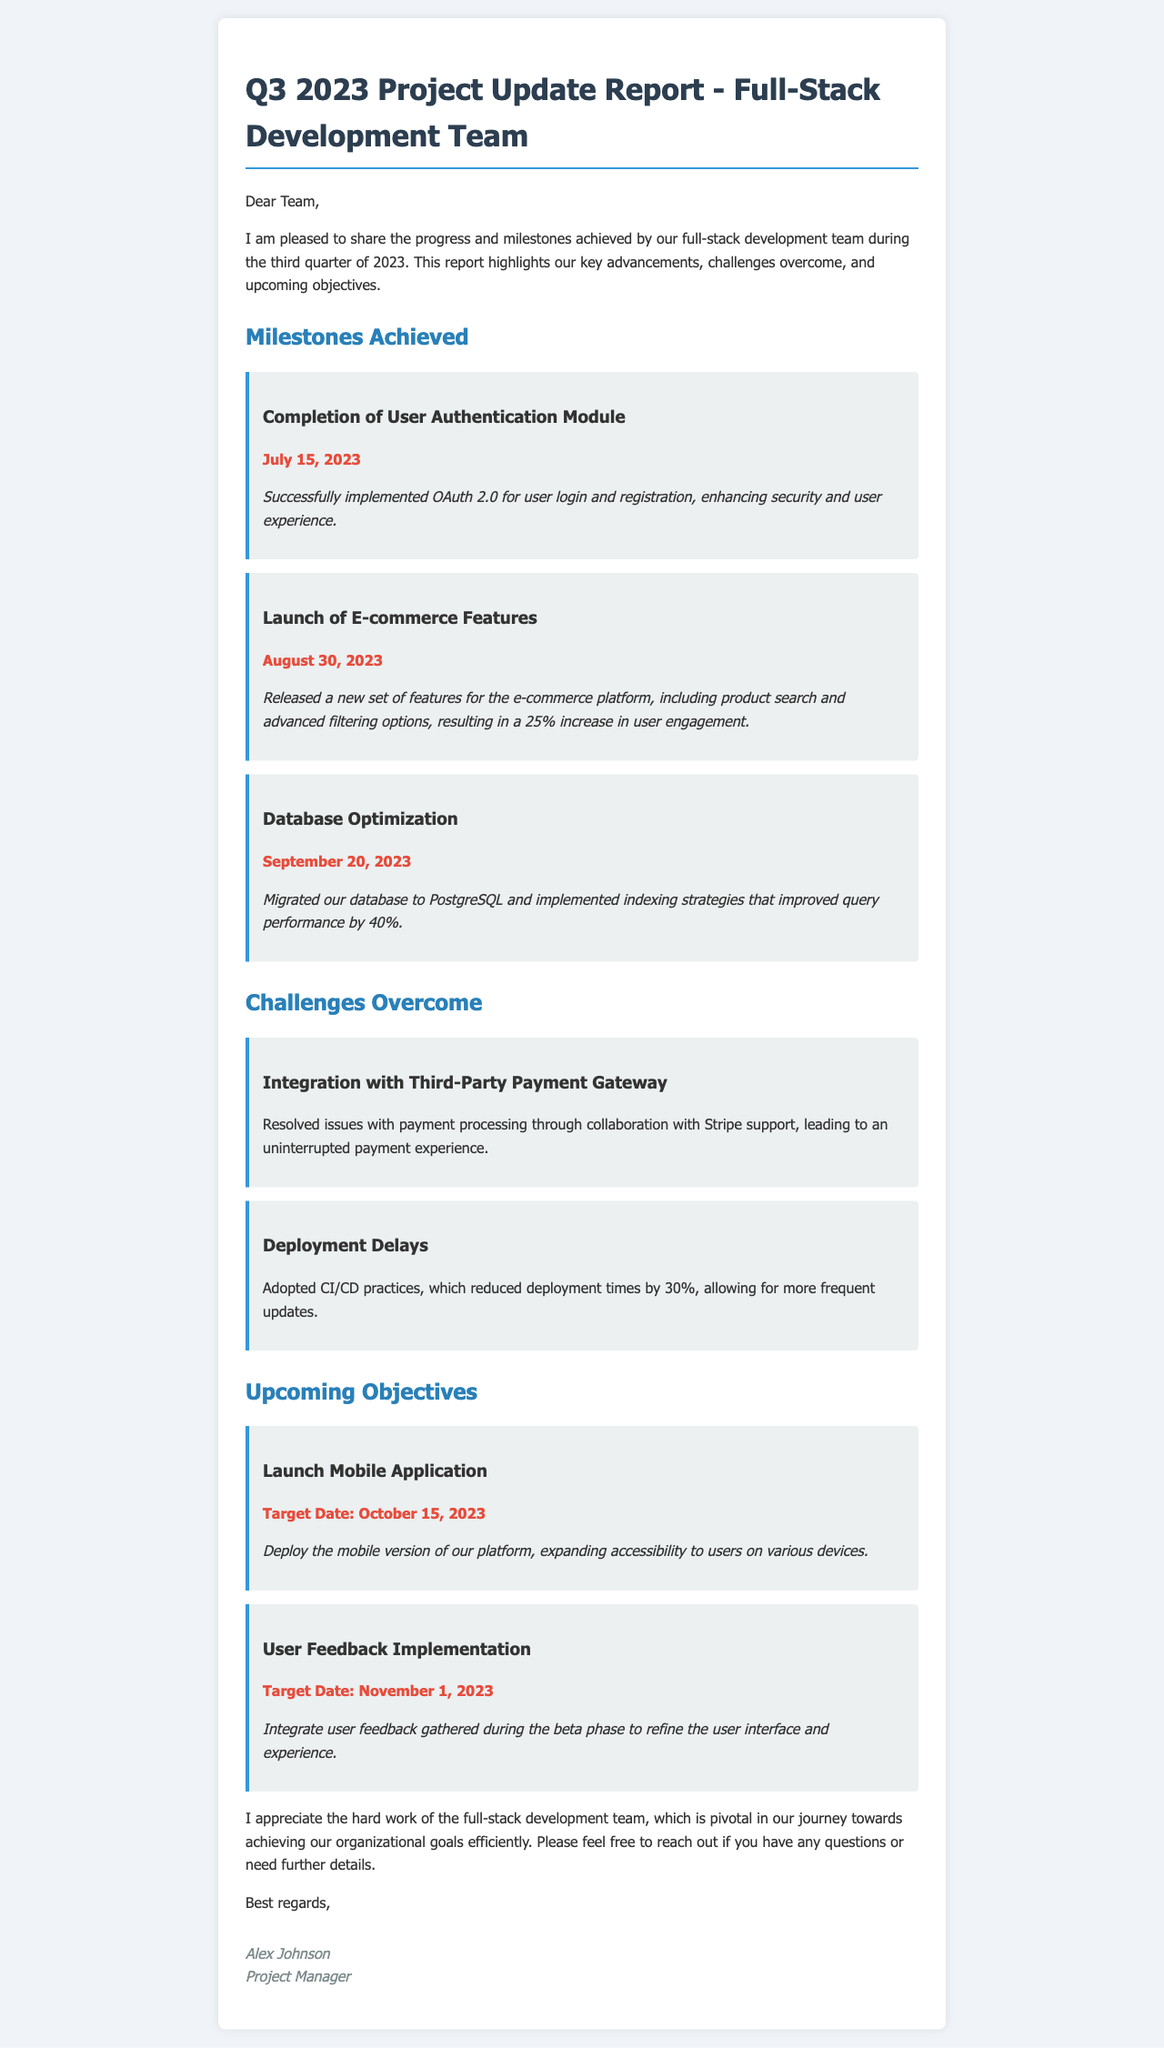What is the title of the report? The title of the report is stated at the top of the document, which is "Q3 2023 Project Update Report - Full-Stack Development Team".
Answer: Q3 2023 Project Update Report - Full-Stack Development Team When was the user authentication module completed? The completion date is explicitly mentioned in the milestones section for the user authentication module, which is July 15, 2023.
Answer: July 15, 2023 What improvement was achieved in query performance? This information is provided in the milestones section regarding database optimization, stating a 40% improvement in query performance.
Answer: 40% What feature release contributed to a 25% increase in user engagement? The document indicates that the launch of e-commerce features resulted in a 25% increase in user engagement.
Answer: E-commerce Features What method did the team adopt to reduce deployment times? The document notes the adoption of CI/CD practices to reduce deployment times, highlighting the strategy used.
Answer: CI/CD practices What is the target date for the launch of the mobile application? This specific date for the mobile application launch is explicitly provided under upcoming objectives, which is October 15, 2023.
Answer: October 15, 2023 Who is the Project Manager? The signature section at the end of the report provides the name of the Project Manager, which is Alex Johnson.
Answer: Alex Johnson How much reduction in deployment time was achieved with CI/CD? The document states that CI/CD practices resulted in a 30% reduction in deployment times.
Answer: 30% 